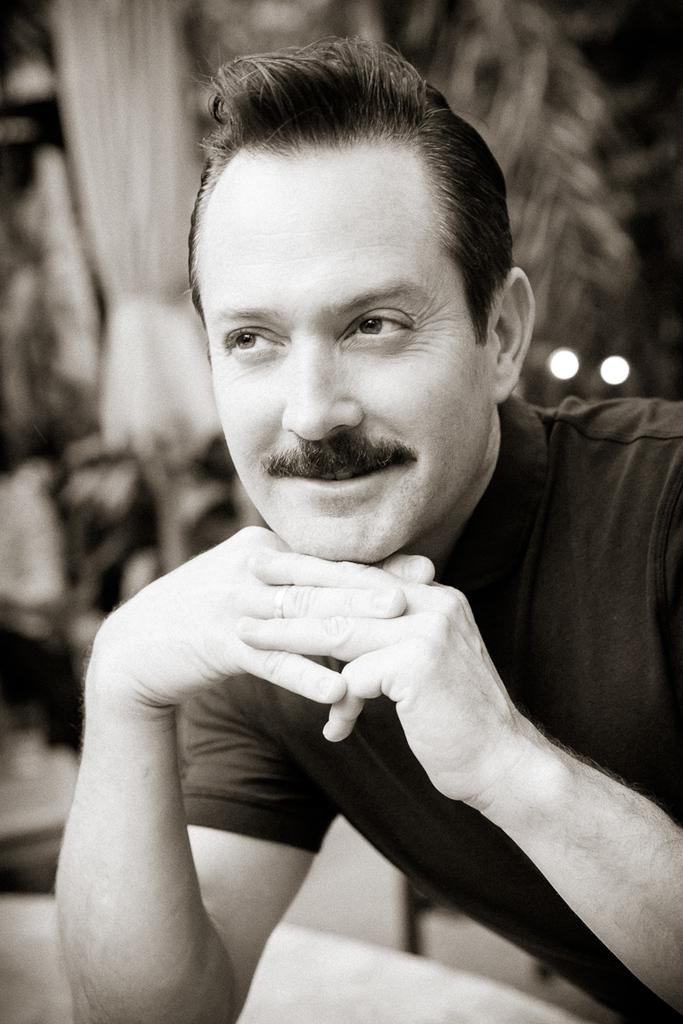What is the main subject in the foreground of the image? There is a man in the foreground of the image. Can you describe the background of the image? The background of the image is blurry. What type of record is the man holding in the image? There is no record present in the image; the man is the only subject visible. 